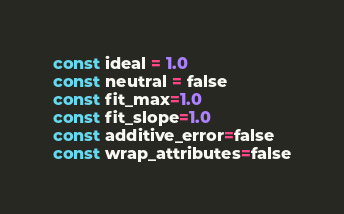<code> <loc_0><loc_0><loc_500><loc_500><_Julia_>const ideal = 1.0
const neutral = false
const fit_max=1.0
const fit_slope=1.0
const additive_error=false
const wrap_attributes=false


</code> 